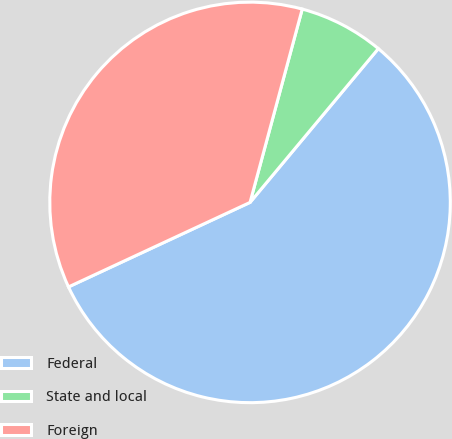Convert chart. <chart><loc_0><loc_0><loc_500><loc_500><pie_chart><fcel>Federal<fcel>State and local<fcel>Foreign<nl><fcel>57.0%<fcel>6.87%<fcel>36.13%<nl></chart> 